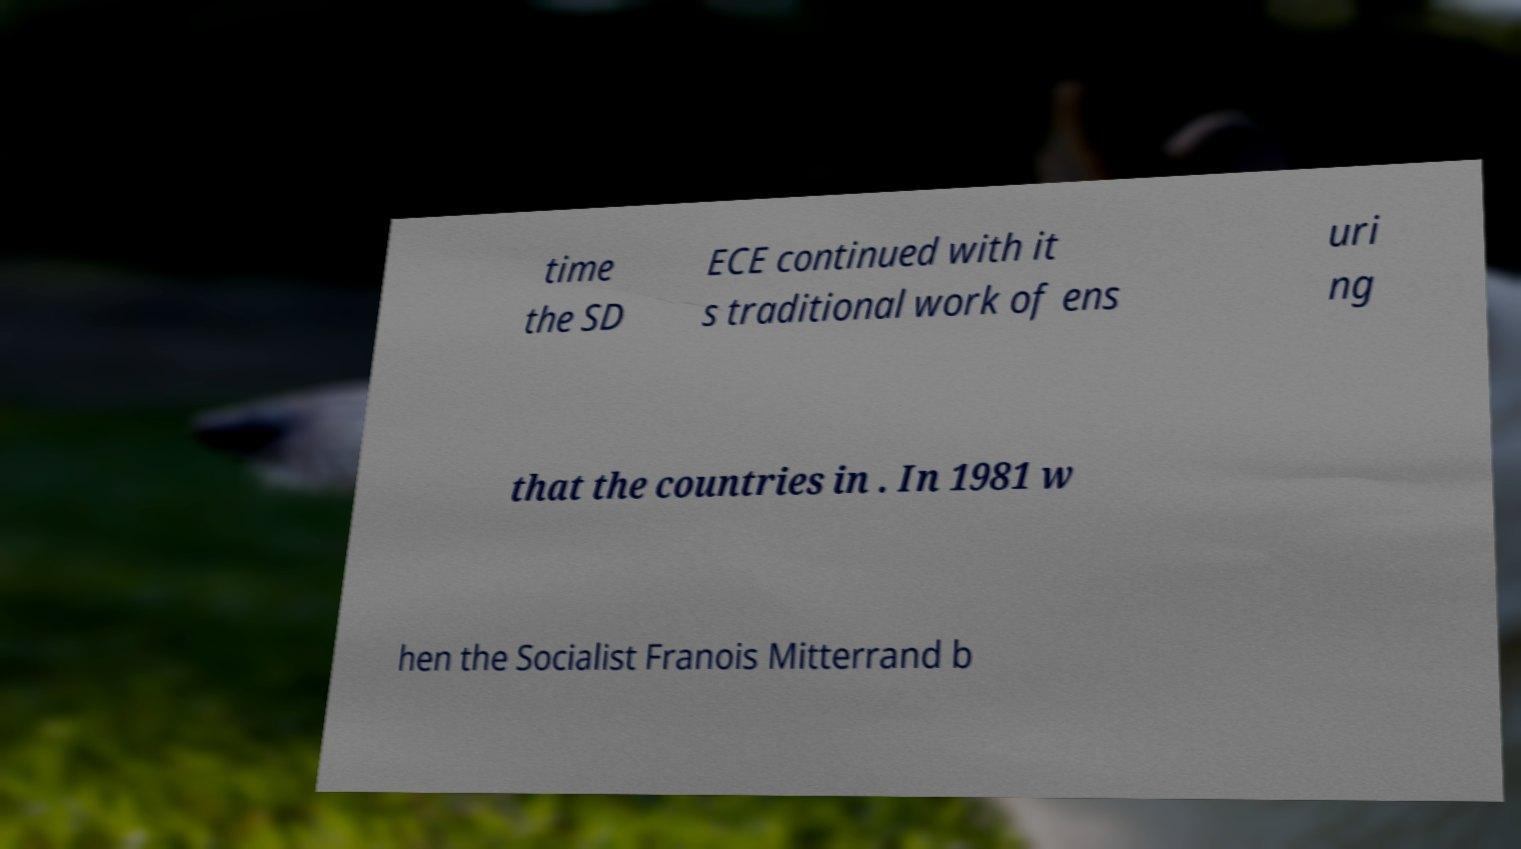Please read and relay the text visible in this image. What does it say? time the SD ECE continued with it s traditional work of ens uri ng that the countries in . In 1981 w hen the Socialist Franois Mitterrand b 